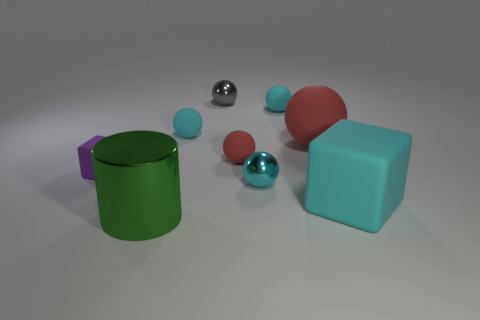What number of spheres are either large green shiny things or cyan things?
Provide a succinct answer. 3. How many things are behind the large red ball and right of the big red ball?
Keep it short and to the point. 0. What is the color of the large matte thing to the left of the large cube?
Keep it short and to the point. Red. What is the size of the other cube that is made of the same material as the small cube?
Give a very brief answer. Large. How many metal balls are in front of the big red matte ball that is right of the small purple rubber thing?
Provide a succinct answer. 1. How many tiny cyan matte spheres are right of the small block?
Your answer should be very brief. 2. What is the color of the big matte object that is behind the tiny thing in front of the block to the left of the large cylinder?
Your answer should be compact. Red. Does the large matte object in front of the tiny red rubber object have the same color as the big object that is behind the tiny purple thing?
Ensure brevity in your answer.  No. There is a cyan matte thing that is in front of the matte block behind the large cyan object; what shape is it?
Make the answer very short. Cube. Is there a red rubber object of the same size as the cyan rubber block?
Your answer should be very brief. Yes. 